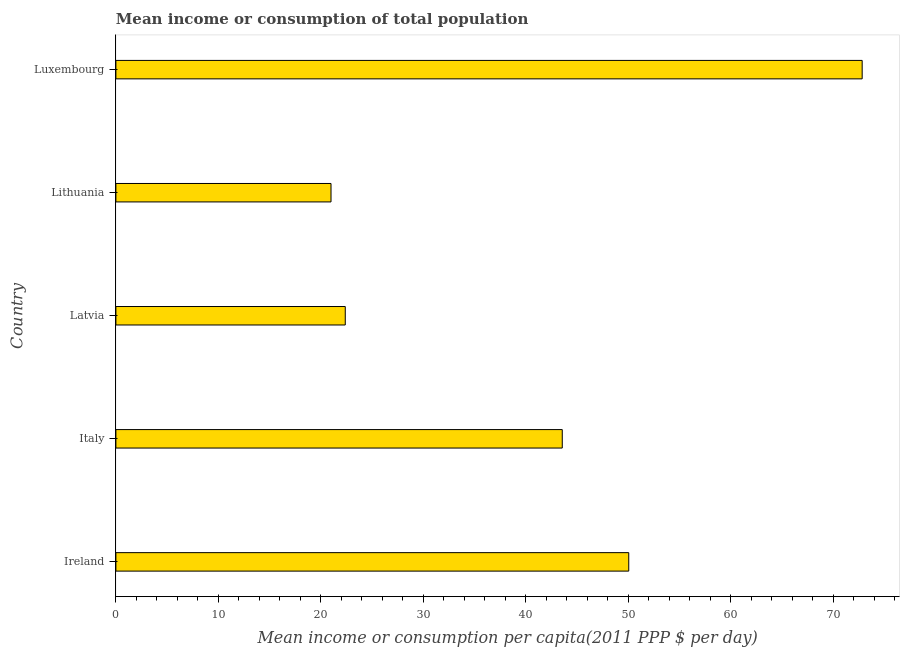Does the graph contain grids?
Provide a short and direct response. No. What is the title of the graph?
Offer a very short reply. Mean income or consumption of total population. What is the label or title of the X-axis?
Make the answer very short. Mean income or consumption per capita(2011 PPP $ per day). What is the mean income or consumption in Ireland?
Make the answer very short. 50.03. Across all countries, what is the maximum mean income or consumption?
Your answer should be very brief. 72.8. Across all countries, what is the minimum mean income or consumption?
Give a very brief answer. 20.99. In which country was the mean income or consumption maximum?
Your answer should be very brief. Luxembourg. In which country was the mean income or consumption minimum?
Ensure brevity in your answer.  Lithuania. What is the sum of the mean income or consumption?
Offer a very short reply. 209.73. What is the difference between the mean income or consumption in Latvia and Lithuania?
Your answer should be compact. 1.39. What is the average mean income or consumption per country?
Offer a terse response. 41.95. What is the median mean income or consumption?
Provide a short and direct response. 43.54. What is the ratio of the mean income or consumption in Latvia to that in Luxembourg?
Keep it short and to the point. 0.31. Is the difference between the mean income or consumption in Latvia and Luxembourg greater than the difference between any two countries?
Provide a succinct answer. No. What is the difference between the highest and the second highest mean income or consumption?
Keep it short and to the point. 22.77. Is the sum of the mean income or consumption in Ireland and Latvia greater than the maximum mean income or consumption across all countries?
Keep it short and to the point. No. What is the difference between the highest and the lowest mean income or consumption?
Give a very brief answer. 51.81. How many countries are there in the graph?
Provide a short and direct response. 5. What is the difference between two consecutive major ticks on the X-axis?
Provide a short and direct response. 10. What is the Mean income or consumption per capita(2011 PPP $ per day) of Ireland?
Make the answer very short. 50.03. What is the Mean income or consumption per capita(2011 PPP $ per day) in Italy?
Provide a succinct answer. 43.54. What is the Mean income or consumption per capita(2011 PPP $ per day) of Latvia?
Your answer should be very brief. 22.38. What is the Mean income or consumption per capita(2011 PPP $ per day) of Lithuania?
Ensure brevity in your answer.  20.99. What is the Mean income or consumption per capita(2011 PPP $ per day) of Luxembourg?
Provide a succinct answer. 72.8. What is the difference between the Mean income or consumption per capita(2011 PPP $ per day) in Ireland and Italy?
Ensure brevity in your answer.  6.49. What is the difference between the Mean income or consumption per capita(2011 PPP $ per day) in Ireland and Latvia?
Provide a succinct answer. 27.65. What is the difference between the Mean income or consumption per capita(2011 PPP $ per day) in Ireland and Lithuania?
Keep it short and to the point. 29.04. What is the difference between the Mean income or consumption per capita(2011 PPP $ per day) in Ireland and Luxembourg?
Your response must be concise. -22.77. What is the difference between the Mean income or consumption per capita(2011 PPP $ per day) in Italy and Latvia?
Offer a very short reply. 21.17. What is the difference between the Mean income or consumption per capita(2011 PPP $ per day) in Italy and Lithuania?
Offer a terse response. 22.56. What is the difference between the Mean income or consumption per capita(2011 PPP $ per day) in Italy and Luxembourg?
Keep it short and to the point. -29.26. What is the difference between the Mean income or consumption per capita(2011 PPP $ per day) in Latvia and Lithuania?
Ensure brevity in your answer.  1.39. What is the difference between the Mean income or consumption per capita(2011 PPP $ per day) in Latvia and Luxembourg?
Make the answer very short. -50.42. What is the difference between the Mean income or consumption per capita(2011 PPP $ per day) in Lithuania and Luxembourg?
Offer a terse response. -51.81. What is the ratio of the Mean income or consumption per capita(2011 PPP $ per day) in Ireland to that in Italy?
Your response must be concise. 1.15. What is the ratio of the Mean income or consumption per capita(2011 PPP $ per day) in Ireland to that in Latvia?
Ensure brevity in your answer.  2.24. What is the ratio of the Mean income or consumption per capita(2011 PPP $ per day) in Ireland to that in Lithuania?
Your response must be concise. 2.38. What is the ratio of the Mean income or consumption per capita(2011 PPP $ per day) in Ireland to that in Luxembourg?
Offer a terse response. 0.69. What is the ratio of the Mean income or consumption per capita(2011 PPP $ per day) in Italy to that in Latvia?
Offer a terse response. 1.95. What is the ratio of the Mean income or consumption per capita(2011 PPP $ per day) in Italy to that in Lithuania?
Offer a very short reply. 2.08. What is the ratio of the Mean income or consumption per capita(2011 PPP $ per day) in Italy to that in Luxembourg?
Provide a succinct answer. 0.6. What is the ratio of the Mean income or consumption per capita(2011 PPP $ per day) in Latvia to that in Lithuania?
Provide a succinct answer. 1.07. What is the ratio of the Mean income or consumption per capita(2011 PPP $ per day) in Latvia to that in Luxembourg?
Your answer should be compact. 0.31. What is the ratio of the Mean income or consumption per capita(2011 PPP $ per day) in Lithuania to that in Luxembourg?
Keep it short and to the point. 0.29. 